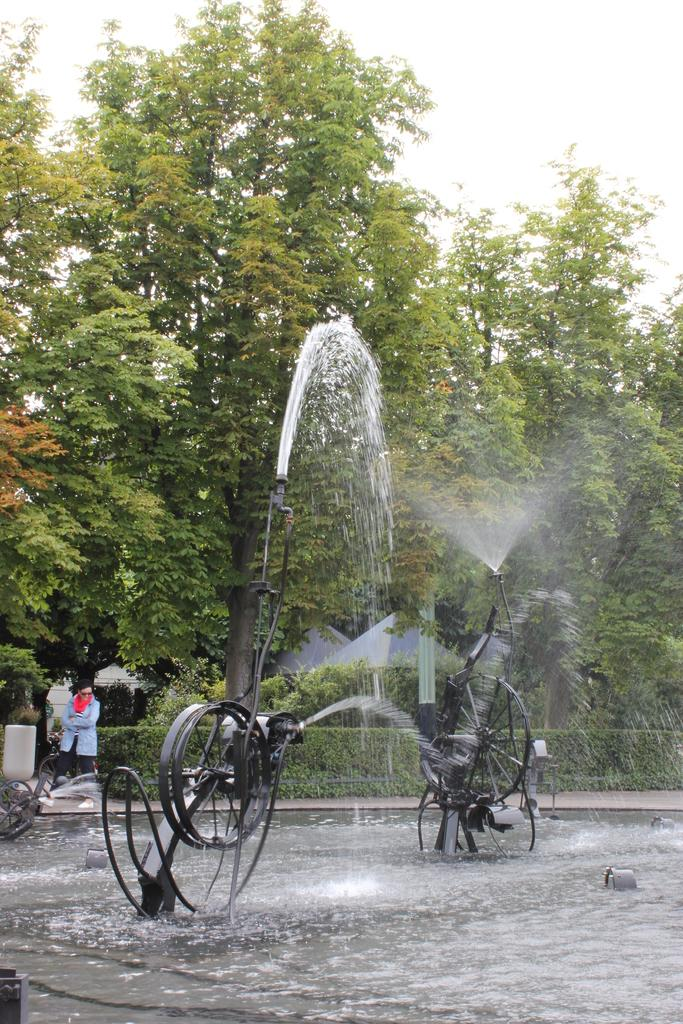What is the main object in the foreground of the image? There is a water sprinkler machine in the foreground of the image. What is the water doing in the image? The water is visible in the image, likely being sprayed by the water sprinkler machine. Can you describe the person in the image? There is a person on the left side of the image. What can be seen in the background of the image? There are trees in the background of the image. What type of goldfish can be seen swimming in the water in the image? There are no goldfish present in the image; it features a water sprinkler machine and water. What songs are being sung by the person in the image? There is no indication in the image that the person is singing any songs. 